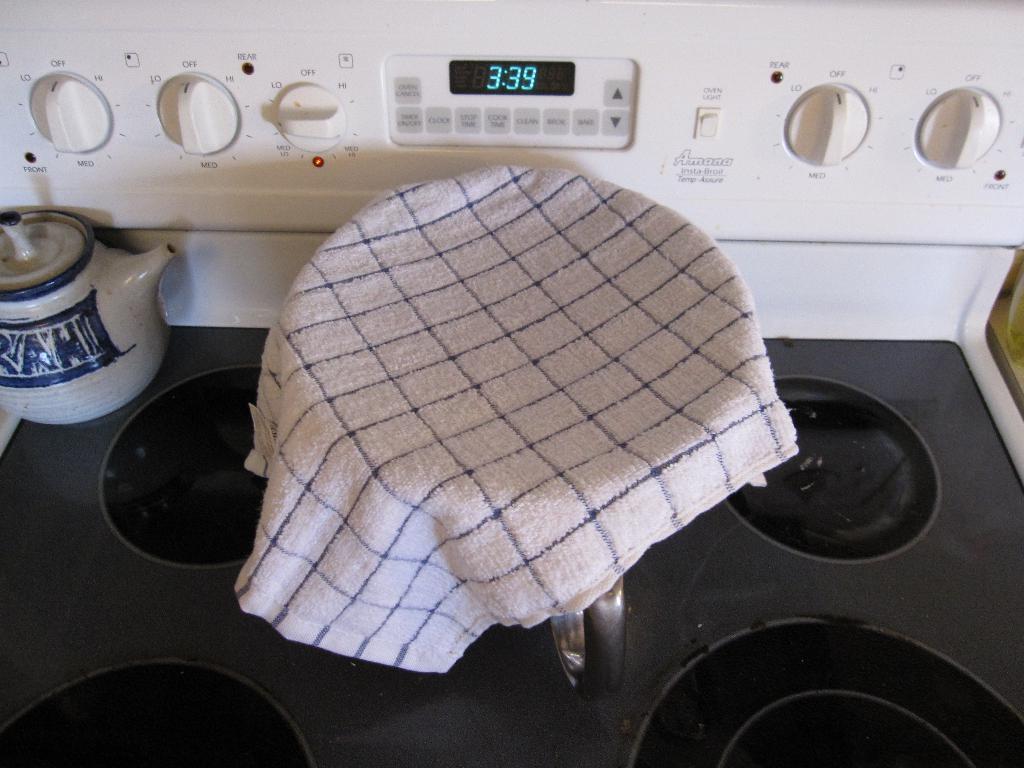What company made the stove?
Give a very brief answer. Amana. 